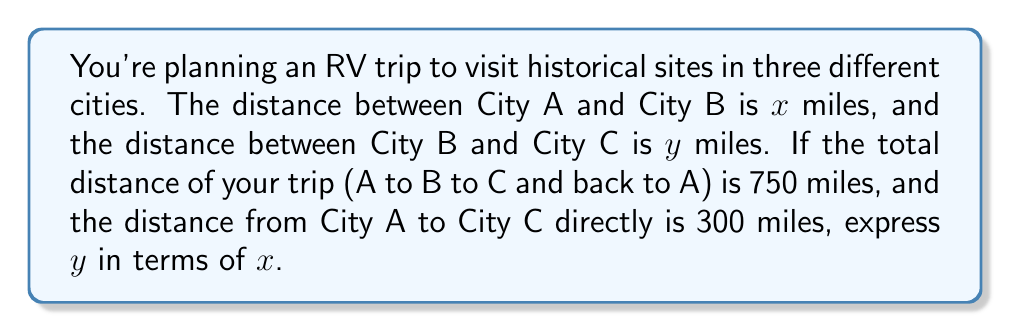Help me with this question. Let's approach this step-by-step:

1) First, let's define the total distance of the trip:
   $$\text{Total Distance} = AB + BC + CA = 750\text{ miles}$$

2) We know that $AB = x$ and $BC = y$. We need to express $CA$ in terms of $x$ and $y$.

3) We can use the triangle inequality theorem, which states that the sum of any two sides of a triangle must be greater than the third side. In this case:
   $$x + y > 300$$
   $$x + 300 > y$$
   $$y + 300 > x$$

4) Given the information, we can set up the equation:
   $$x + y + 300 = 750$$

5) Simplify the equation:
   $$x + y = 450$$

6) Now, we need to express $y$ in terms of $x$:
   $$y = 450 - x$$

This is the equation that expresses $y$ in terms of $x$.
Answer: $y = 450 - x$ 